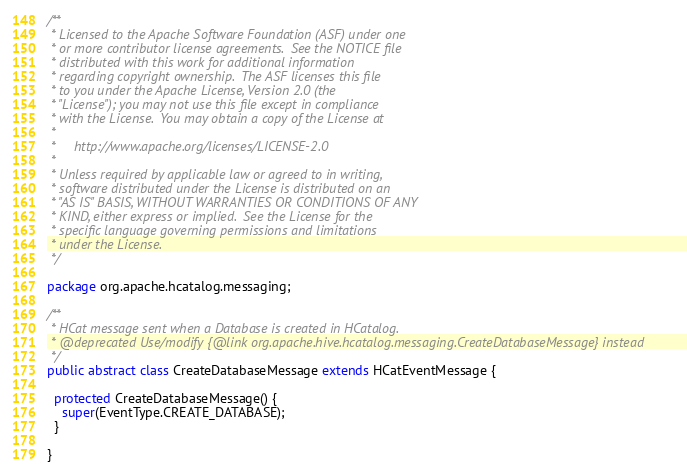Convert code to text. <code><loc_0><loc_0><loc_500><loc_500><_Java_>/**
 * Licensed to the Apache Software Foundation (ASF) under one
 * or more contributor license agreements.  See the NOTICE file
 * distributed with this work for additional information
 * regarding copyright ownership.  The ASF licenses this file
 * to you under the Apache License, Version 2.0 (the
 * "License"); you may not use this file except in compliance
 * with the License.  You may obtain a copy of the License at
 *
 *     http://www.apache.org/licenses/LICENSE-2.0
 *
 * Unless required by applicable law or agreed to in writing,
 * software distributed under the License is distributed on an
 * "AS IS" BASIS, WITHOUT WARRANTIES OR CONDITIONS OF ANY
 * KIND, either express or implied.  See the License for the
 * specific language governing permissions and limitations
 * under the License.
 */

package org.apache.hcatalog.messaging;

/**
 * HCat message sent when a Database is created in HCatalog.
 * @deprecated Use/modify {@link org.apache.hive.hcatalog.messaging.CreateDatabaseMessage} instead
 */
public abstract class CreateDatabaseMessage extends HCatEventMessage {

  protected CreateDatabaseMessage() {
    super(EventType.CREATE_DATABASE);
  }

}
</code> 